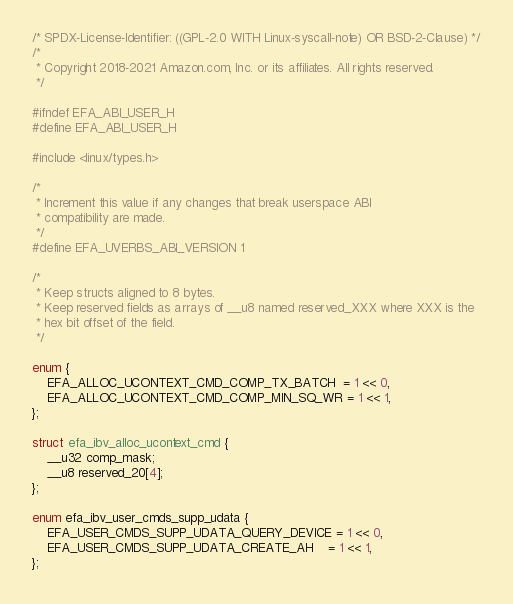<code> <loc_0><loc_0><loc_500><loc_500><_C_>/* SPDX-License-Identifier: ((GPL-2.0 WITH Linux-syscall-note) OR BSD-2-Clause) */
/*
 * Copyright 2018-2021 Amazon.com, Inc. or its affiliates. All rights reserved.
 */

#ifndef EFA_ABI_USER_H
#define EFA_ABI_USER_H

#include <linux/types.h>

/*
 * Increment this value if any changes that break userspace ABI
 * compatibility are made.
 */
#define EFA_UVERBS_ABI_VERSION 1

/*
 * Keep structs aligned to 8 bytes.
 * Keep reserved fields as arrays of __u8 named reserved_XXX where XXX is the
 * hex bit offset of the field.
 */

enum {
	EFA_ALLOC_UCONTEXT_CMD_COMP_TX_BATCH  = 1 << 0,
	EFA_ALLOC_UCONTEXT_CMD_COMP_MIN_SQ_WR = 1 << 1,
};

struct efa_ibv_alloc_ucontext_cmd {
	__u32 comp_mask;
	__u8 reserved_20[4];
};

enum efa_ibv_user_cmds_supp_udata {
	EFA_USER_CMDS_SUPP_UDATA_QUERY_DEVICE = 1 << 0,
	EFA_USER_CMDS_SUPP_UDATA_CREATE_AH    = 1 << 1,
};
</code> 